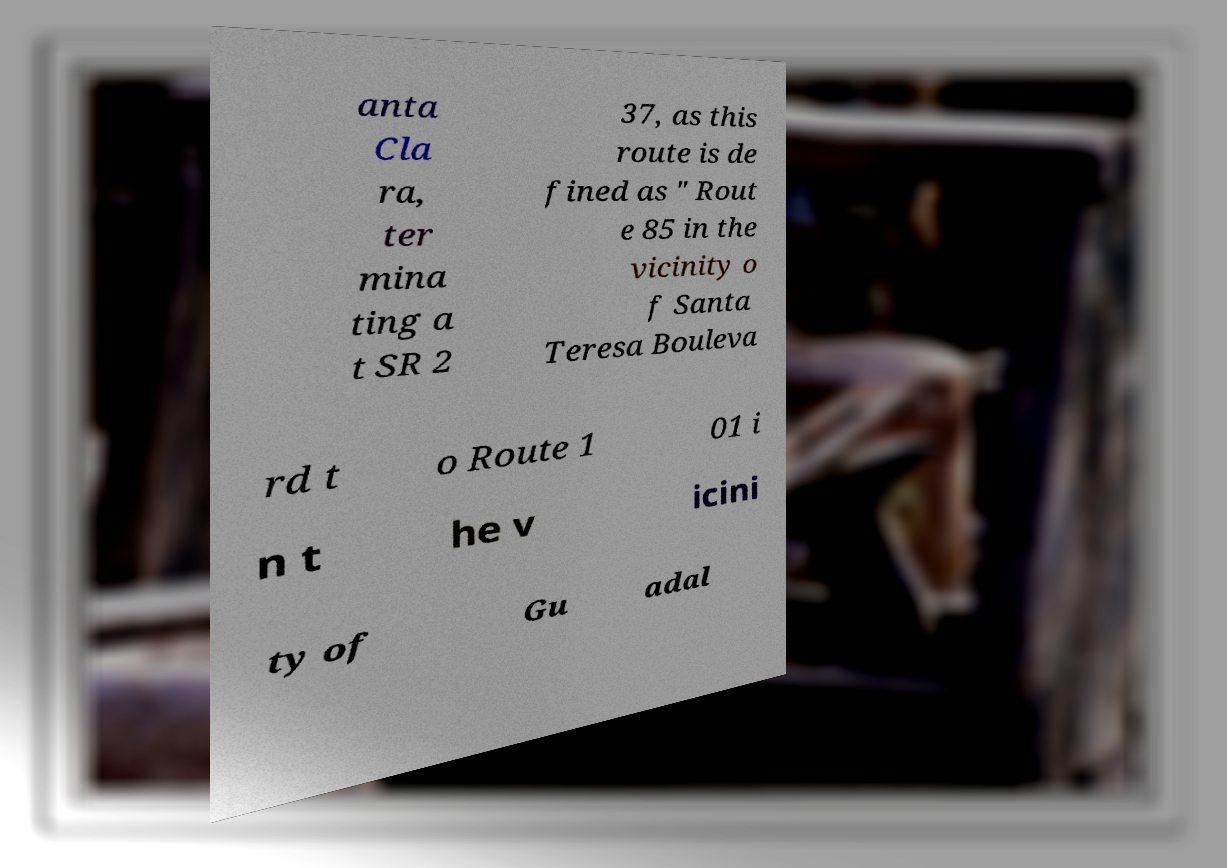For documentation purposes, I need the text within this image transcribed. Could you provide that? anta Cla ra, ter mina ting a t SR 2 37, as this route is de fined as " Rout e 85 in the vicinity o f Santa Teresa Bouleva rd t o Route 1 01 i n t he v icini ty of Gu adal 